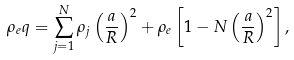<formula> <loc_0><loc_0><loc_500><loc_500>\rho _ { e } q = \sum _ { j = 1 } ^ { N } \rho _ { j } \left ( \frac { a } { R } \right ) ^ { 2 } + \rho _ { e } \left [ 1 - N \left ( \frac { a } { R } \right ) ^ { 2 } \right ] ,</formula> 